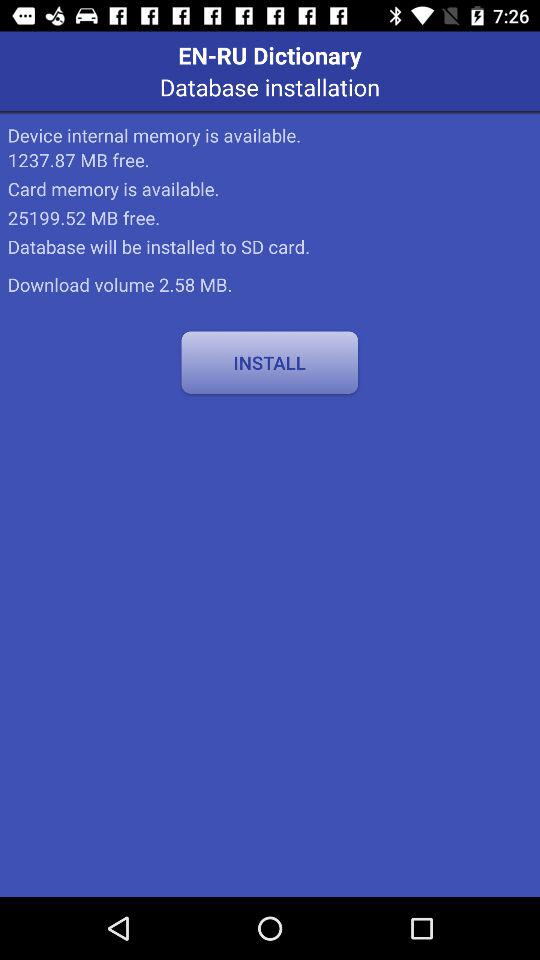How much "Device internal memory" is available? The available memory is 1237.87 MB. 